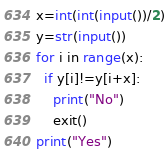<code> <loc_0><loc_0><loc_500><loc_500><_Python_>x=int(int(input())/2)
y=str(input())
for i in range(x):
  if y[i]!=y[i+x]:
    print("No")
    exit()
print("Yes")</code> 